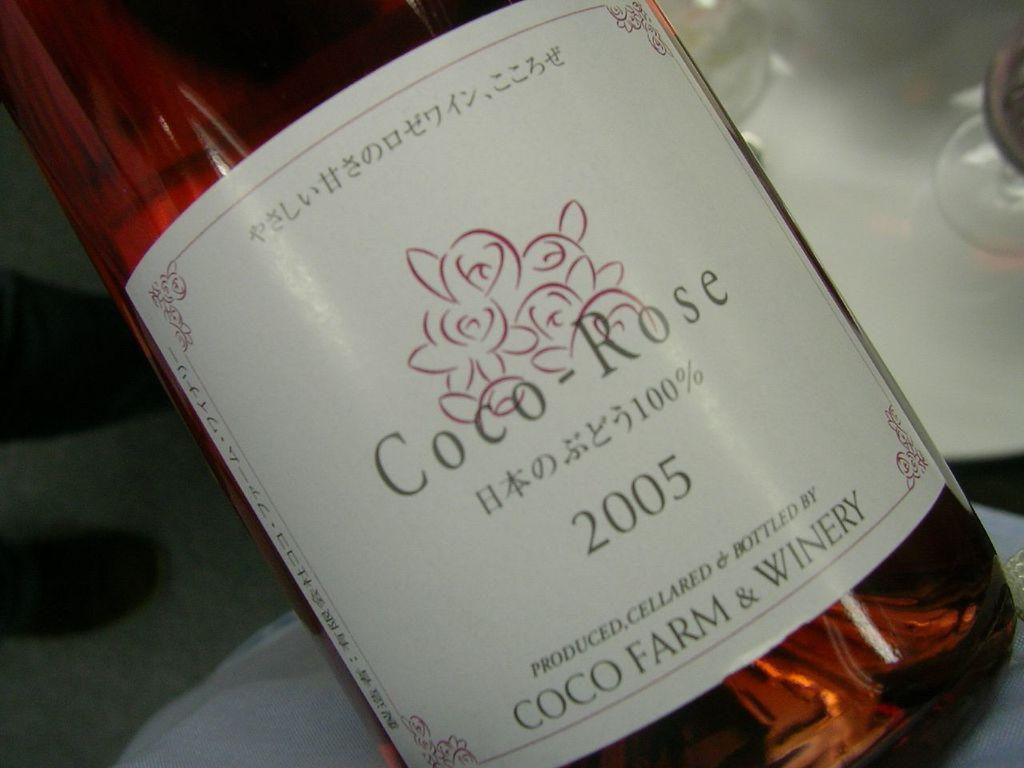<image>
Render a clear and concise summary of the photo. A bottle of wine with Coco Farm and Winery on the label. 